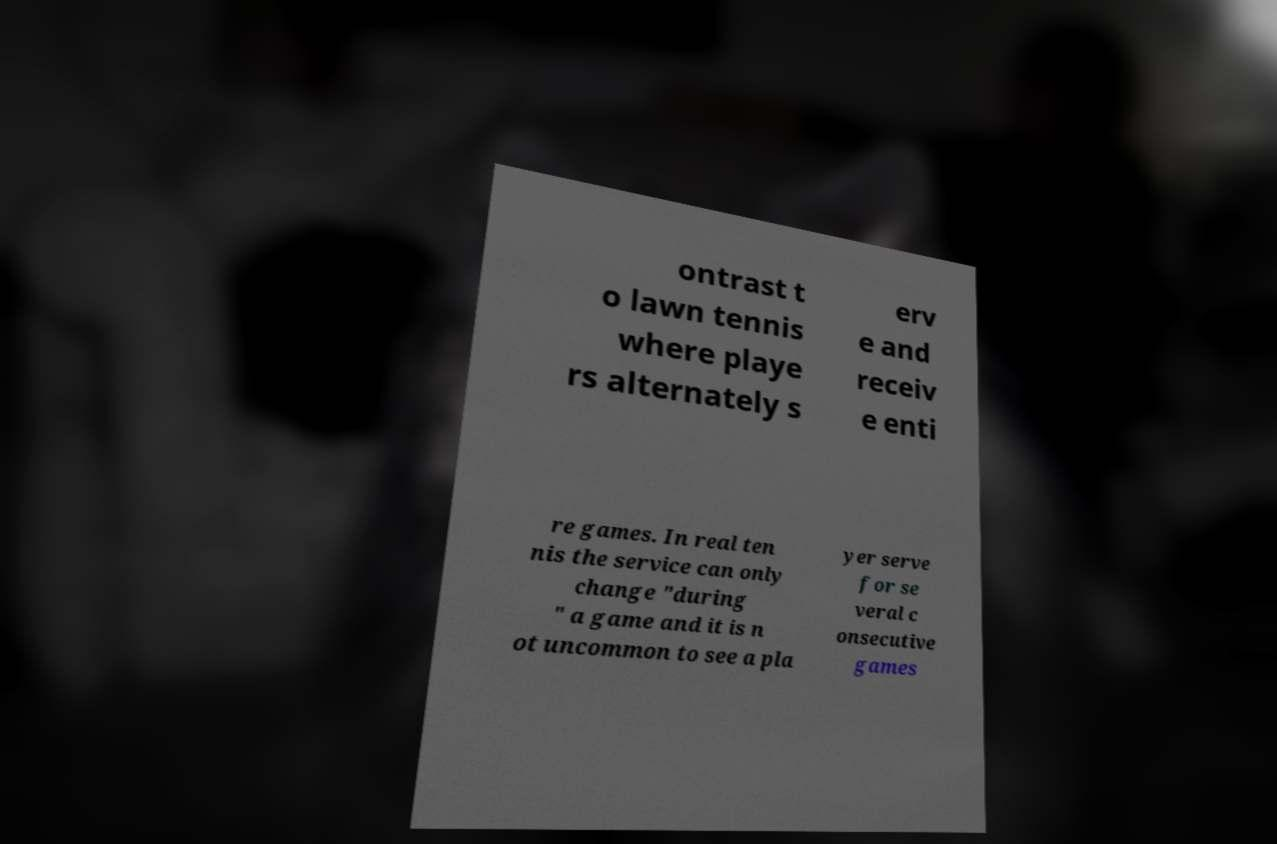I need the written content from this picture converted into text. Can you do that? ontrast t o lawn tennis where playe rs alternately s erv e and receiv e enti re games. In real ten nis the service can only change "during " a game and it is n ot uncommon to see a pla yer serve for se veral c onsecutive games 